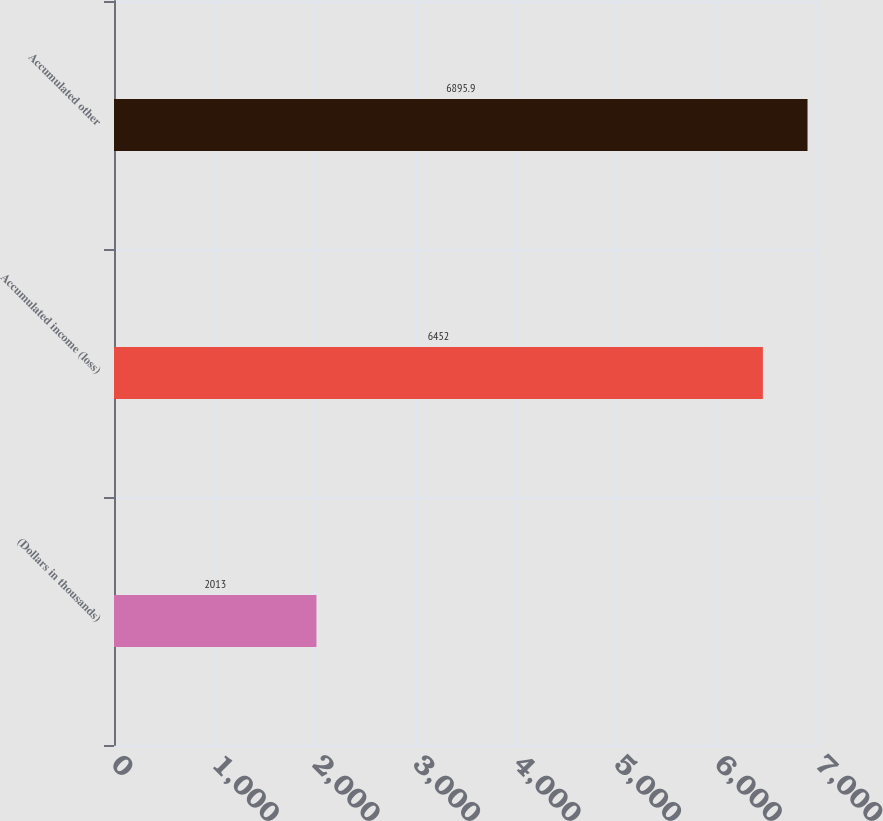Convert chart to OTSL. <chart><loc_0><loc_0><loc_500><loc_500><bar_chart><fcel>(Dollars in thousands)<fcel>Accumulated income (loss)<fcel>Accumulated other<nl><fcel>2013<fcel>6452<fcel>6895.9<nl></chart> 